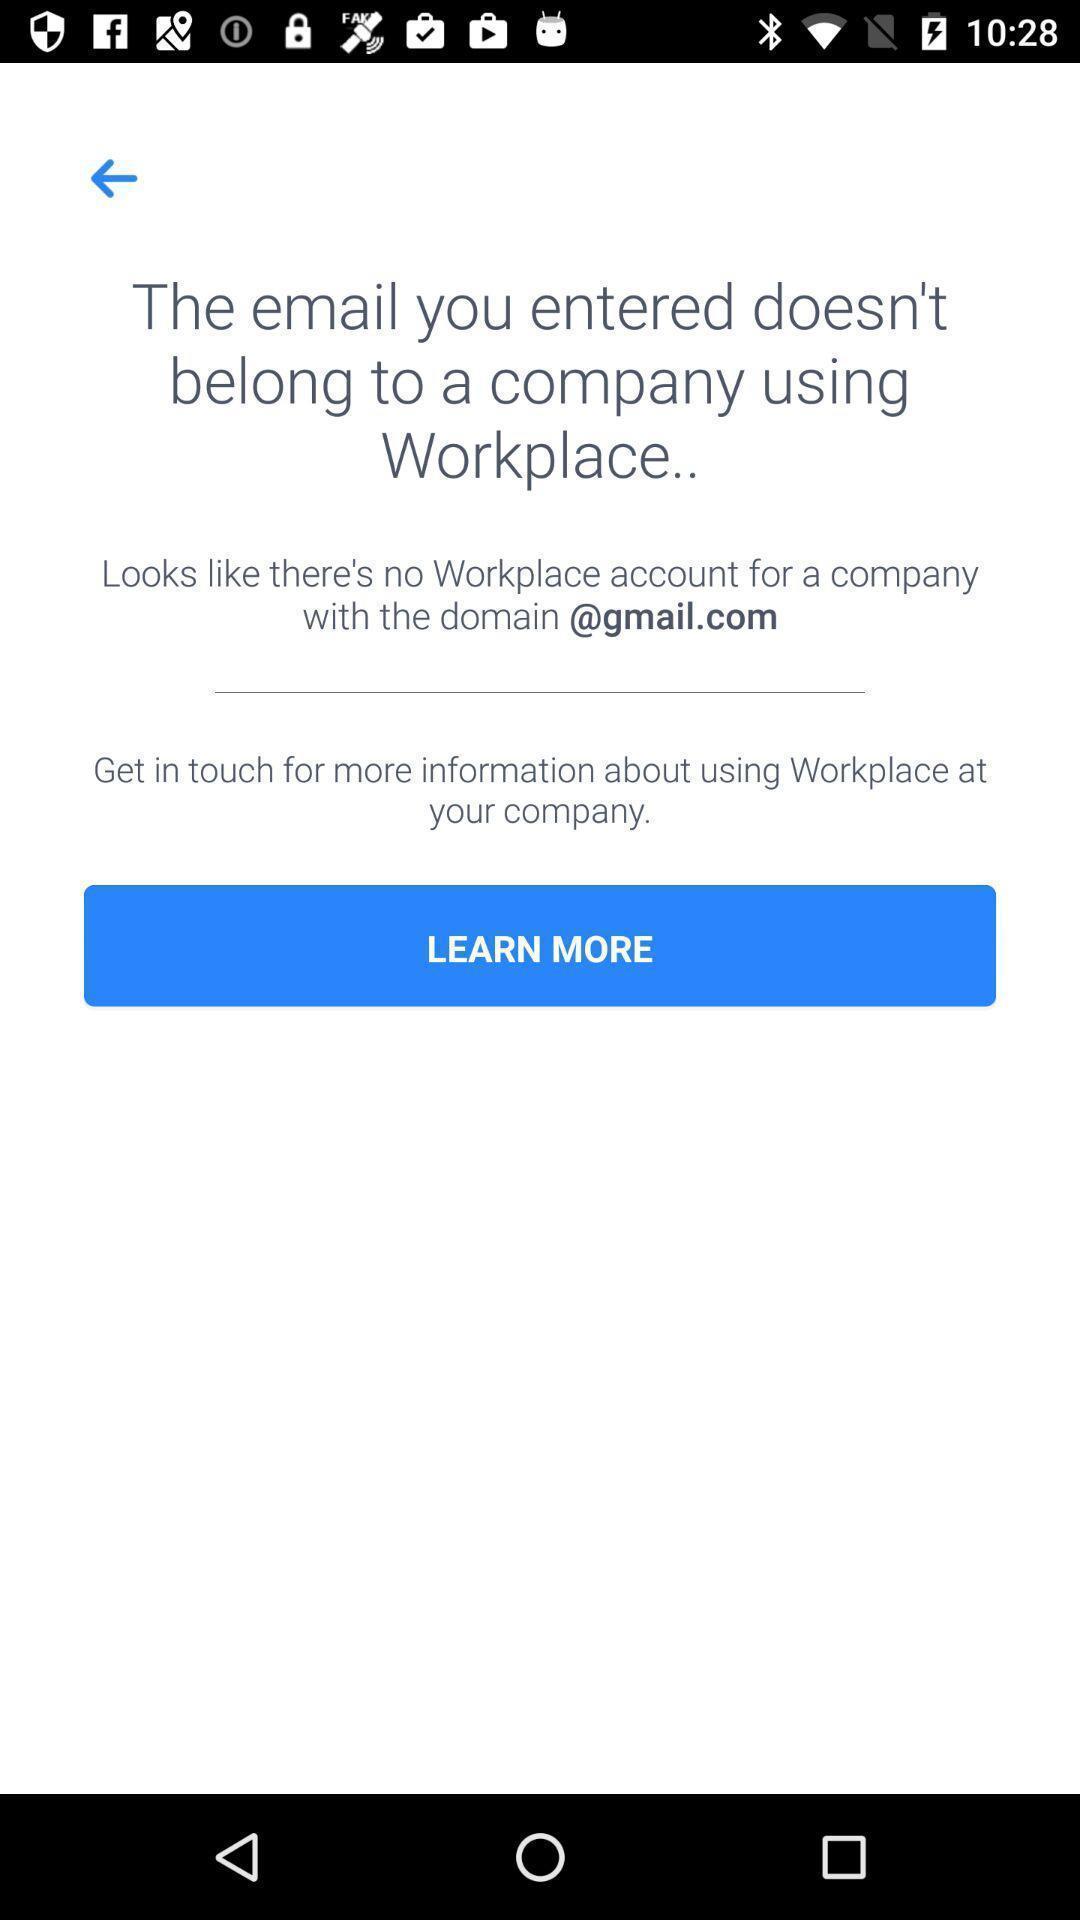Describe the key features of this screenshot. Screen display learn more option. 